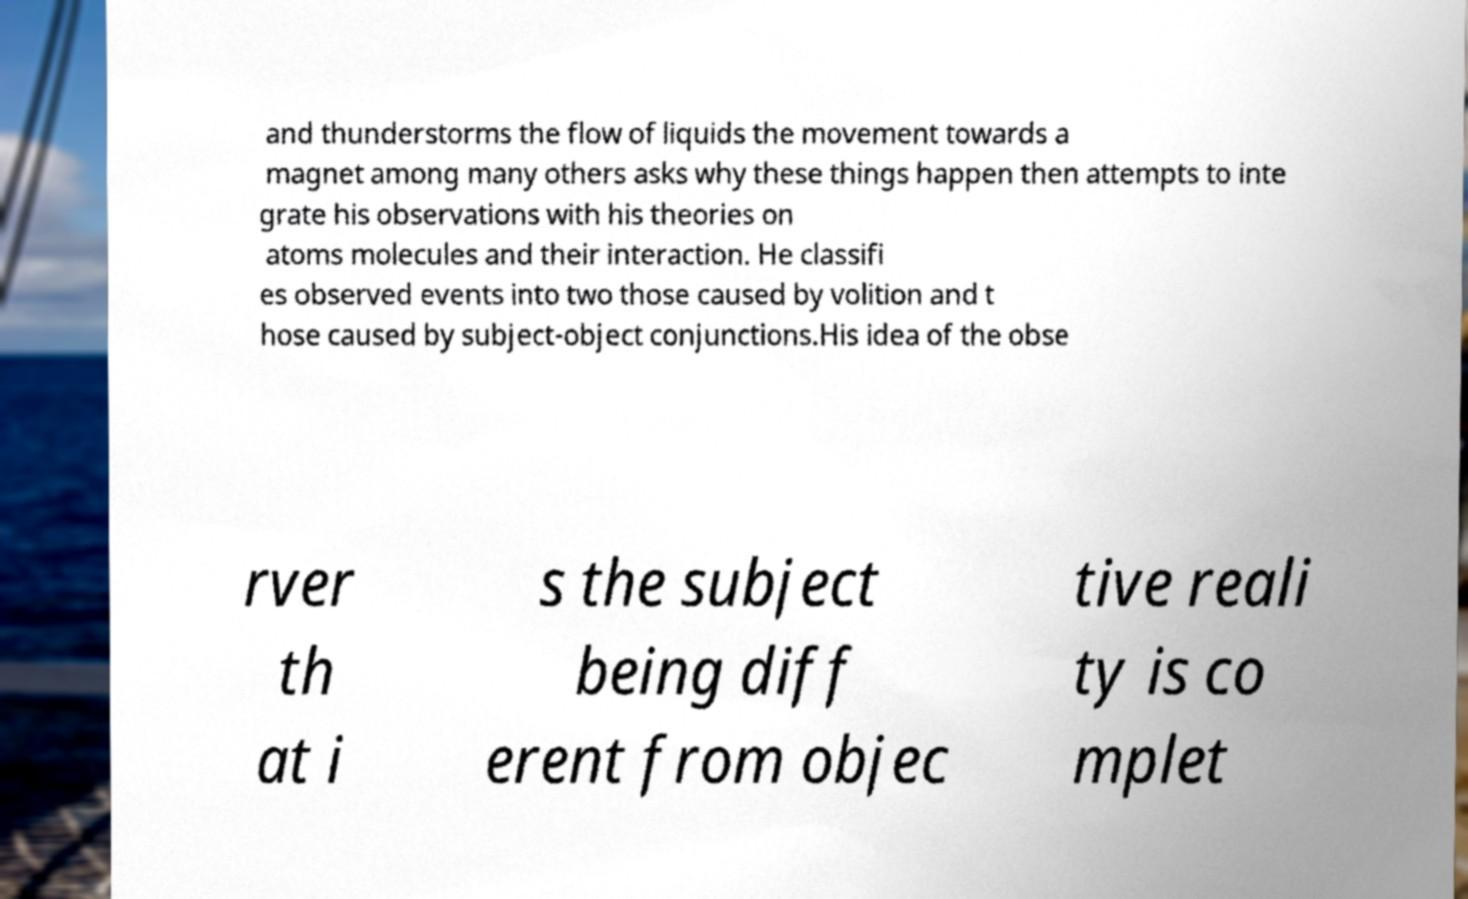Could you extract and type out the text from this image? and thunderstorms the flow of liquids the movement towards a magnet among many others asks why these things happen then attempts to inte grate his observations with his theories on atoms molecules and their interaction. He classifi es observed events into two those caused by volition and t hose caused by subject-object conjunctions.His idea of the obse rver th at i s the subject being diff erent from objec tive reali ty is co mplet 